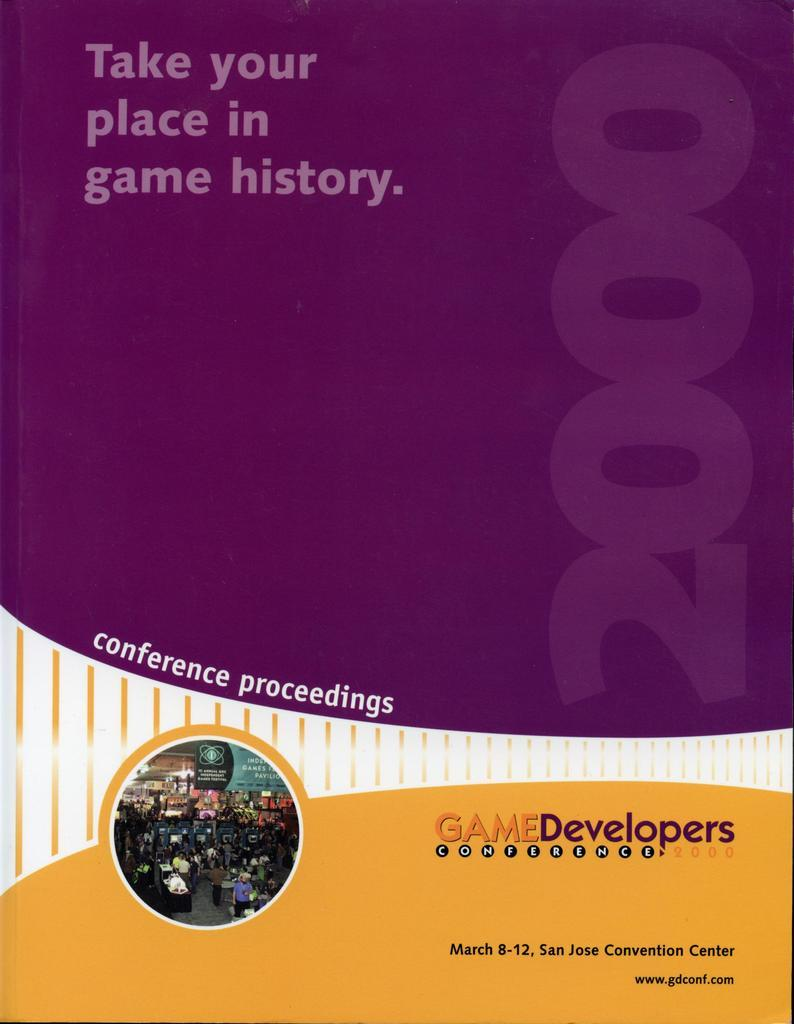<image>
Write a terse but informative summary of the picture. poster for game developers conference on march 8-12, 2000 